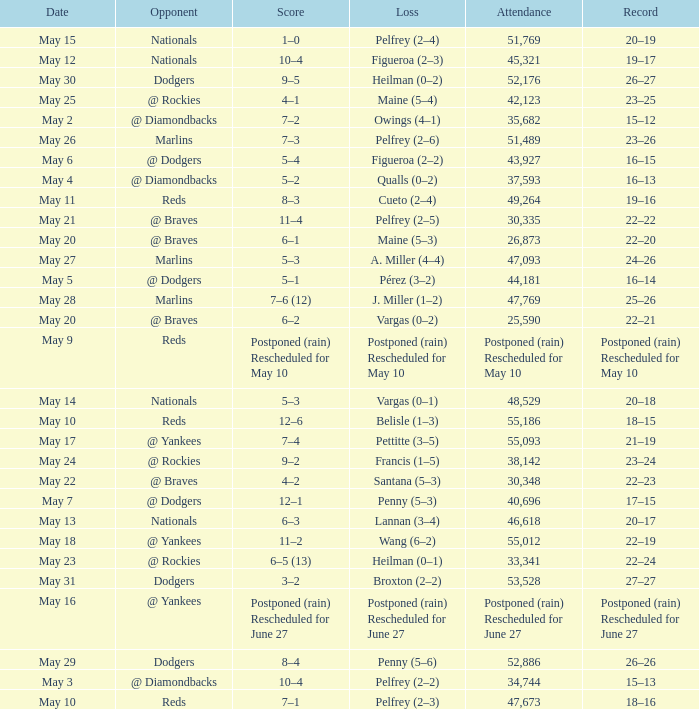Attendance of 30,335 had what record? 22–22. 